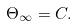Convert formula to latex. <formula><loc_0><loc_0><loc_500><loc_500>\Theta _ { \infty } = C .</formula> 